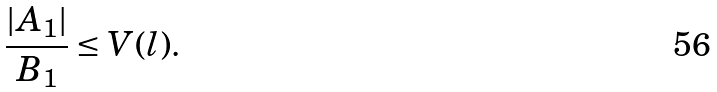Convert formula to latex. <formula><loc_0><loc_0><loc_500><loc_500>\frac { | A _ { 1 } | } { B _ { 1 } } \leq V ( l ) .</formula> 